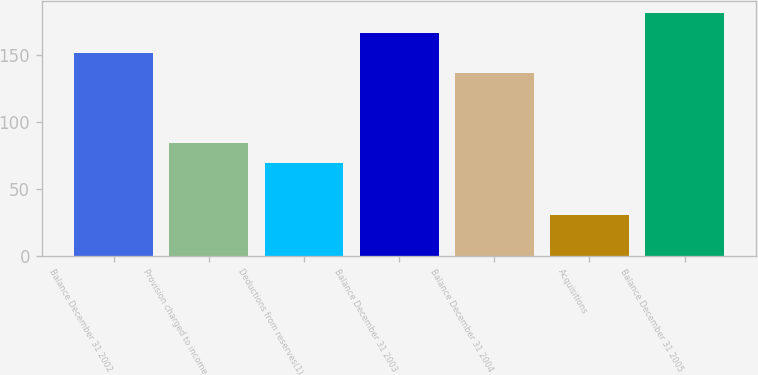<chart> <loc_0><loc_0><loc_500><loc_500><bar_chart><fcel>Balance December 31 2002<fcel>Provision charged to income<fcel>Deductions from reserves(1)<fcel>Balance December 31 2003<fcel>Balance December 31 2004<fcel>Acquisitions<fcel>Balance December 31 2005<nl><fcel>151.9<fcel>83.9<fcel>69<fcel>166.8<fcel>137<fcel>30<fcel>181.7<nl></chart> 